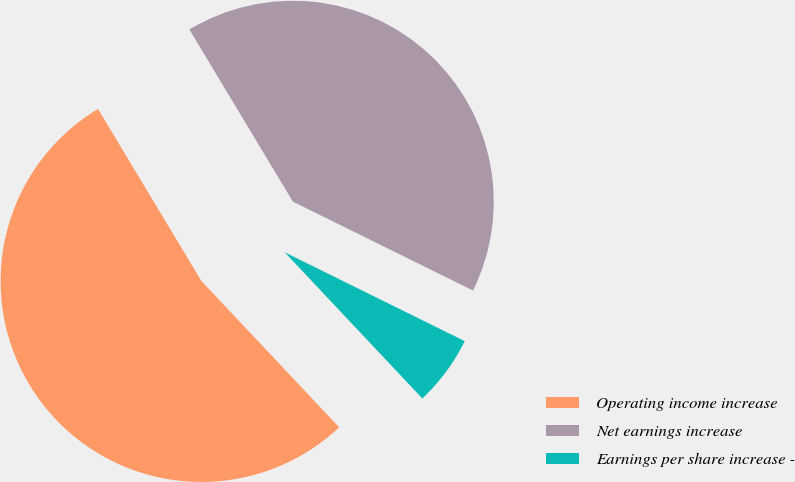Convert chart to OTSL. <chart><loc_0><loc_0><loc_500><loc_500><pie_chart><fcel>Operating income increase<fcel>Net earnings increase<fcel>Earnings per share increase -<nl><fcel>53.41%<fcel>40.91%<fcel>5.68%<nl></chart> 